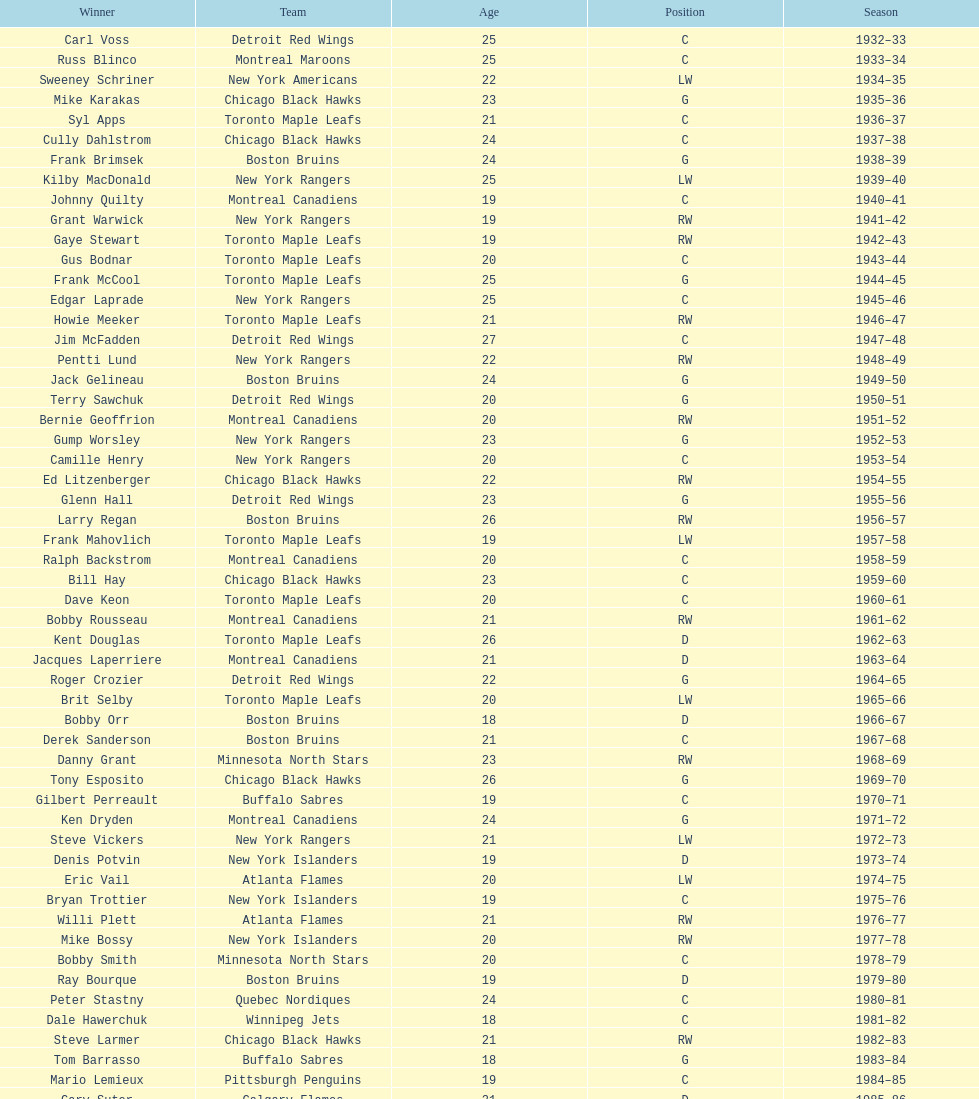How many times did the toronto maple leaves win? 9. 